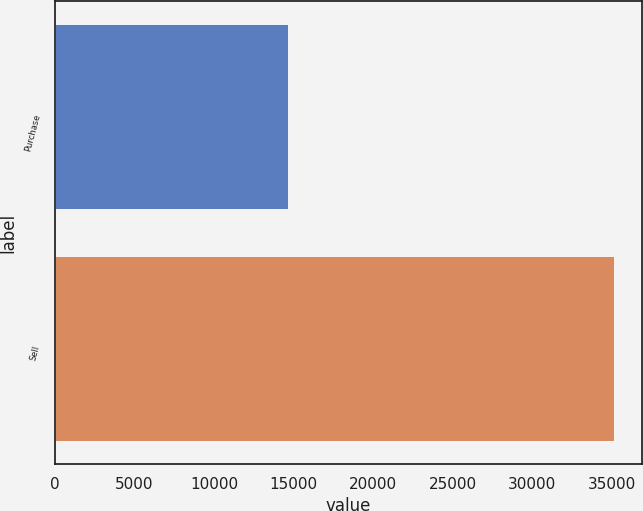Convert chart to OTSL. <chart><loc_0><loc_0><loc_500><loc_500><bar_chart><fcel>Purchase<fcel>Sell<nl><fcel>14641<fcel>35178<nl></chart> 